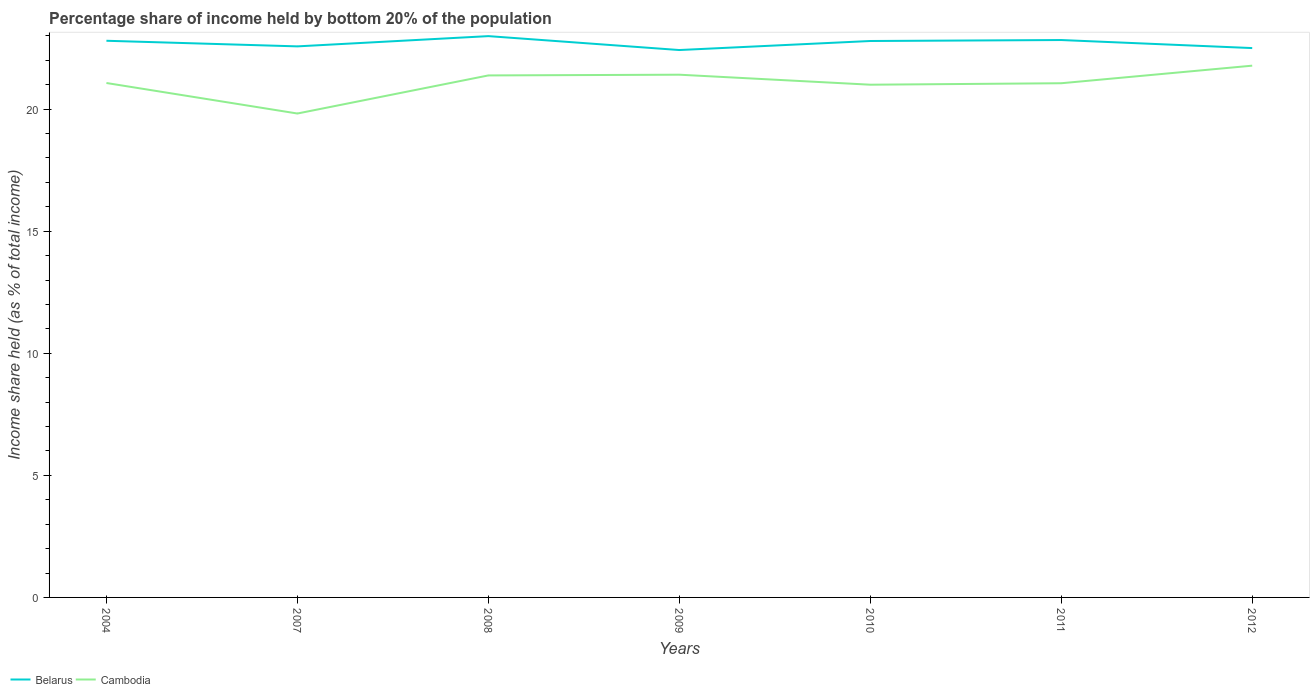How many different coloured lines are there?
Provide a succinct answer. 2. Is the number of lines equal to the number of legend labels?
Ensure brevity in your answer.  Yes. Across all years, what is the maximum share of income held by bottom 20% of the population in Cambodia?
Provide a succinct answer. 19.82. What is the total share of income held by bottom 20% of the population in Belarus in the graph?
Provide a short and direct response. -0.04. What is the difference between the highest and the second highest share of income held by bottom 20% of the population in Cambodia?
Ensure brevity in your answer.  1.96. What is the difference between the highest and the lowest share of income held by bottom 20% of the population in Cambodia?
Your response must be concise. 3. How many years are there in the graph?
Give a very brief answer. 7. What is the difference between two consecutive major ticks on the Y-axis?
Provide a succinct answer. 5. Does the graph contain grids?
Provide a succinct answer. No. Where does the legend appear in the graph?
Your response must be concise. Bottom left. What is the title of the graph?
Keep it short and to the point. Percentage share of income held by bottom 20% of the population. Does "St. Vincent and the Grenadines" appear as one of the legend labels in the graph?
Ensure brevity in your answer.  No. What is the label or title of the Y-axis?
Offer a very short reply. Income share held (as % of total income). What is the Income share held (as % of total income) of Belarus in 2004?
Offer a very short reply. 22.8. What is the Income share held (as % of total income) in Cambodia in 2004?
Your answer should be compact. 21.07. What is the Income share held (as % of total income) in Belarus in 2007?
Keep it short and to the point. 22.57. What is the Income share held (as % of total income) in Cambodia in 2007?
Your response must be concise. 19.82. What is the Income share held (as % of total income) in Belarus in 2008?
Provide a succinct answer. 22.99. What is the Income share held (as % of total income) of Cambodia in 2008?
Offer a very short reply. 21.38. What is the Income share held (as % of total income) of Belarus in 2009?
Keep it short and to the point. 22.42. What is the Income share held (as % of total income) in Cambodia in 2009?
Your response must be concise. 21.41. What is the Income share held (as % of total income) of Belarus in 2010?
Offer a very short reply. 22.79. What is the Income share held (as % of total income) of Belarus in 2011?
Your answer should be compact. 22.83. What is the Income share held (as % of total income) in Cambodia in 2011?
Provide a short and direct response. 21.06. What is the Income share held (as % of total income) of Cambodia in 2012?
Your answer should be compact. 21.78. Across all years, what is the maximum Income share held (as % of total income) in Belarus?
Your response must be concise. 22.99. Across all years, what is the maximum Income share held (as % of total income) of Cambodia?
Give a very brief answer. 21.78. Across all years, what is the minimum Income share held (as % of total income) of Belarus?
Keep it short and to the point. 22.42. Across all years, what is the minimum Income share held (as % of total income) of Cambodia?
Your response must be concise. 19.82. What is the total Income share held (as % of total income) of Belarus in the graph?
Make the answer very short. 158.9. What is the total Income share held (as % of total income) in Cambodia in the graph?
Your response must be concise. 147.52. What is the difference between the Income share held (as % of total income) of Belarus in 2004 and that in 2007?
Your response must be concise. 0.23. What is the difference between the Income share held (as % of total income) of Belarus in 2004 and that in 2008?
Your response must be concise. -0.19. What is the difference between the Income share held (as % of total income) in Cambodia in 2004 and that in 2008?
Offer a very short reply. -0.31. What is the difference between the Income share held (as % of total income) in Belarus in 2004 and that in 2009?
Make the answer very short. 0.38. What is the difference between the Income share held (as % of total income) of Cambodia in 2004 and that in 2009?
Your answer should be compact. -0.34. What is the difference between the Income share held (as % of total income) in Belarus in 2004 and that in 2010?
Your answer should be very brief. 0.01. What is the difference between the Income share held (as % of total income) in Cambodia in 2004 and that in 2010?
Offer a terse response. 0.07. What is the difference between the Income share held (as % of total income) of Belarus in 2004 and that in 2011?
Keep it short and to the point. -0.03. What is the difference between the Income share held (as % of total income) of Cambodia in 2004 and that in 2011?
Your response must be concise. 0.01. What is the difference between the Income share held (as % of total income) of Belarus in 2004 and that in 2012?
Offer a very short reply. 0.3. What is the difference between the Income share held (as % of total income) of Cambodia in 2004 and that in 2012?
Make the answer very short. -0.71. What is the difference between the Income share held (as % of total income) of Belarus in 2007 and that in 2008?
Offer a terse response. -0.42. What is the difference between the Income share held (as % of total income) in Cambodia in 2007 and that in 2008?
Provide a succinct answer. -1.56. What is the difference between the Income share held (as % of total income) in Belarus in 2007 and that in 2009?
Make the answer very short. 0.15. What is the difference between the Income share held (as % of total income) of Cambodia in 2007 and that in 2009?
Ensure brevity in your answer.  -1.59. What is the difference between the Income share held (as % of total income) of Belarus in 2007 and that in 2010?
Offer a terse response. -0.22. What is the difference between the Income share held (as % of total income) of Cambodia in 2007 and that in 2010?
Your answer should be compact. -1.18. What is the difference between the Income share held (as % of total income) of Belarus in 2007 and that in 2011?
Offer a very short reply. -0.26. What is the difference between the Income share held (as % of total income) in Cambodia in 2007 and that in 2011?
Offer a terse response. -1.24. What is the difference between the Income share held (as % of total income) of Belarus in 2007 and that in 2012?
Your response must be concise. 0.07. What is the difference between the Income share held (as % of total income) in Cambodia in 2007 and that in 2012?
Your answer should be very brief. -1.96. What is the difference between the Income share held (as % of total income) in Belarus in 2008 and that in 2009?
Make the answer very short. 0.57. What is the difference between the Income share held (as % of total income) in Cambodia in 2008 and that in 2009?
Your answer should be very brief. -0.03. What is the difference between the Income share held (as % of total income) of Cambodia in 2008 and that in 2010?
Keep it short and to the point. 0.38. What is the difference between the Income share held (as % of total income) in Belarus in 2008 and that in 2011?
Your response must be concise. 0.16. What is the difference between the Income share held (as % of total income) in Cambodia in 2008 and that in 2011?
Make the answer very short. 0.32. What is the difference between the Income share held (as % of total income) of Belarus in 2008 and that in 2012?
Your answer should be very brief. 0.49. What is the difference between the Income share held (as % of total income) in Cambodia in 2008 and that in 2012?
Your response must be concise. -0.4. What is the difference between the Income share held (as % of total income) in Belarus in 2009 and that in 2010?
Give a very brief answer. -0.37. What is the difference between the Income share held (as % of total income) of Cambodia in 2009 and that in 2010?
Provide a short and direct response. 0.41. What is the difference between the Income share held (as % of total income) in Belarus in 2009 and that in 2011?
Provide a succinct answer. -0.41. What is the difference between the Income share held (as % of total income) in Cambodia in 2009 and that in 2011?
Provide a succinct answer. 0.35. What is the difference between the Income share held (as % of total income) of Belarus in 2009 and that in 2012?
Keep it short and to the point. -0.08. What is the difference between the Income share held (as % of total income) of Cambodia in 2009 and that in 2012?
Your answer should be compact. -0.37. What is the difference between the Income share held (as % of total income) of Belarus in 2010 and that in 2011?
Offer a terse response. -0.04. What is the difference between the Income share held (as % of total income) in Cambodia in 2010 and that in 2011?
Your answer should be very brief. -0.06. What is the difference between the Income share held (as % of total income) of Belarus in 2010 and that in 2012?
Your answer should be very brief. 0.29. What is the difference between the Income share held (as % of total income) of Cambodia in 2010 and that in 2012?
Make the answer very short. -0.78. What is the difference between the Income share held (as % of total income) in Belarus in 2011 and that in 2012?
Your response must be concise. 0.33. What is the difference between the Income share held (as % of total income) of Cambodia in 2011 and that in 2012?
Your answer should be very brief. -0.72. What is the difference between the Income share held (as % of total income) in Belarus in 2004 and the Income share held (as % of total income) in Cambodia in 2007?
Provide a short and direct response. 2.98. What is the difference between the Income share held (as % of total income) of Belarus in 2004 and the Income share held (as % of total income) of Cambodia in 2008?
Your answer should be very brief. 1.42. What is the difference between the Income share held (as % of total income) of Belarus in 2004 and the Income share held (as % of total income) of Cambodia in 2009?
Offer a very short reply. 1.39. What is the difference between the Income share held (as % of total income) in Belarus in 2004 and the Income share held (as % of total income) in Cambodia in 2010?
Keep it short and to the point. 1.8. What is the difference between the Income share held (as % of total income) of Belarus in 2004 and the Income share held (as % of total income) of Cambodia in 2011?
Give a very brief answer. 1.74. What is the difference between the Income share held (as % of total income) of Belarus in 2004 and the Income share held (as % of total income) of Cambodia in 2012?
Your answer should be compact. 1.02. What is the difference between the Income share held (as % of total income) in Belarus in 2007 and the Income share held (as % of total income) in Cambodia in 2008?
Offer a terse response. 1.19. What is the difference between the Income share held (as % of total income) of Belarus in 2007 and the Income share held (as % of total income) of Cambodia in 2009?
Offer a very short reply. 1.16. What is the difference between the Income share held (as % of total income) of Belarus in 2007 and the Income share held (as % of total income) of Cambodia in 2010?
Your answer should be compact. 1.57. What is the difference between the Income share held (as % of total income) of Belarus in 2007 and the Income share held (as % of total income) of Cambodia in 2011?
Your answer should be very brief. 1.51. What is the difference between the Income share held (as % of total income) of Belarus in 2007 and the Income share held (as % of total income) of Cambodia in 2012?
Your answer should be compact. 0.79. What is the difference between the Income share held (as % of total income) in Belarus in 2008 and the Income share held (as % of total income) in Cambodia in 2009?
Your answer should be compact. 1.58. What is the difference between the Income share held (as % of total income) of Belarus in 2008 and the Income share held (as % of total income) of Cambodia in 2010?
Your response must be concise. 1.99. What is the difference between the Income share held (as % of total income) of Belarus in 2008 and the Income share held (as % of total income) of Cambodia in 2011?
Provide a succinct answer. 1.93. What is the difference between the Income share held (as % of total income) in Belarus in 2008 and the Income share held (as % of total income) in Cambodia in 2012?
Make the answer very short. 1.21. What is the difference between the Income share held (as % of total income) in Belarus in 2009 and the Income share held (as % of total income) in Cambodia in 2010?
Provide a short and direct response. 1.42. What is the difference between the Income share held (as % of total income) in Belarus in 2009 and the Income share held (as % of total income) in Cambodia in 2011?
Your answer should be compact. 1.36. What is the difference between the Income share held (as % of total income) in Belarus in 2009 and the Income share held (as % of total income) in Cambodia in 2012?
Give a very brief answer. 0.64. What is the difference between the Income share held (as % of total income) of Belarus in 2010 and the Income share held (as % of total income) of Cambodia in 2011?
Offer a very short reply. 1.73. What is the average Income share held (as % of total income) in Belarus per year?
Offer a very short reply. 22.7. What is the average Income share held (as % of total income) of Cambodia per year?
Your answer should be compact. 21.07. In the year 2004, what is the difference between the Income share held (as % of total income) of Belarus and Income share held (as % of total income) of Cambodia?
Your answer should be compact. 1.73. In the year 2007, what is the difference between the Income share held (as % of total income) of Belarus and Income share held (as % of total income) of Cambodia?
Your answer should be very brief. 2.75. In the year 2008, what is the difference between the Income share held (as % of total income) in Belarus and Income share held (as % of total income) in Cambodia?
Offer a very short reply. 1.61. In the year 2010, what is the difference between the Income share held (as % of total income) of Belarus and Income share held (as % of total income) of Cambodia?
Your answer should be very brief. 1.79. In the year 2011, what is the difference between the Income share held (as % of total income) in Belarus and Income share held (as % of total income) in Cambodia?
Make the answer very short. 1.77. In the year 2012, what is the difference between the Income share held (as % of total income) in Belarus and Income share held (as % of total income) in Cambodia?
Provide a short and direct response. 0.72. What is the ratio of the Income share held (as % of total income) of Belarus in 2004 to that in 2007?
Your answer should be very brief. 1.01. What is the ratio of the Income share held (as % of total income) of Cambodia in 2004 to that in 2007?
Ensure brevity in your answer.  1.06. What is the ratio of the Income share held (as % of total income) of Cambodia in 2004 to that in 2008?
Provide a short and direct response. 0.99. What is the ratio of the Income share held (as % of total income) in Belarus in 2004 to that in 2009?
Provide a succinct answer. 1.02. What is the ratio of the Income share held (as % of total income) of Cambodia in 2004 to that in 2009?
Provide a short and direct response. 0.98. What is the ratio of the Income share held (as % of total income) in Belarus in 2004 to that in 2010?
Keep it short and to the point. 1. What is the ratio of the Income share held (as % of total income) of Cambodia in 2004 to that in 2010?
Provide a succinct answer. 1. What is the ratio of the Income share held (as % of total income) of Belarus in 2004 to that in 2012?
Keep it short and to the point. 1.01. What is the ratio of the Income share held (as % of total income) in Cambodia in 2004 to that in 2012?
Keep it short and to the point. 0.97. What is the ratio of the Income share held (as % of total income) of Belarus in 2007 to that in 2008?
Offer a very short reply. 0.98. What is the ratio of the Income share held (as % of total income) of Cambodia in 2007 to that in 2008?
Ensure brevity in your answer.  0.93. What is the ratio of the Income share held (as % of total income) of Belarus in 2007 to that in 2009?
Offer a very short reply. 1.01. What is the ratio of the Income share held (as % of total income) of Cambodia in 2007 to that in 2009?
Offer a very short reply. 0.93. What is the ratio of the Income share held (as % of total income) of Belarus in 2007 to that in 2010?
Give a very brief answer. 0.99. What is the ratio of the Income share held (as % of total income) in Cambodia in 2007 to that in 2010?
Your response must be concise. 0.94. What is the ratio of the Income share held (as % of total income) of Cambodia in 2007 to that in 2011?
Your answer should be very brief. 0.94. What is the ratio of the Income share held (as % of total income) in Belarus in 2007 to that in 2012?
Your answer should be very brief. 1. What is the ratio of the Income share held (as % of total income) of Cambodia in 2007 to that in 2012?
Offer a very short reply. 0.91. What is the ratio of the Income share held (as % of total income) of Belarus in 2008 to that in 2009?
Provide a succinct answer. 1.03. What is the ratio of the Income share held (as % of total income) in Belarus in 2008 to that in 2010?
Provide a succinct answer. 1.01. What is the ratio of the Income share held (as % of total income) of Cambodia in 2008 to that in 2010?
Your response must be concise. 1.02. What is the ratio of the Income share held (as % of total income) of Belarus in 2008 to that in 2011?
Provide a short and direct response. 1.01. What is the ratio of the Income share held (as % of total income) in Cambodia in 2008 to that in 2011?
Your answer should be very brief. 1.02. What is the ratio of the Income share held (as % of total income) of Belarus in 2008 to that in 2012?
Offer a terse response. 1.02. What is the ratio of the Income share held (as % of total income) in Cambodia in 2008 to that in 2012?
Keep it short and to the point. 0.98. What is the ratio of the Income share held (as % of total income) of Belarus in 2009 to that in 2010?
Provide a succinct answer. 0.98. What is the ratio of the Income share held (as % of total income) of Cambodia in 2009 to that in 2010?
Offer a terse response. 1.02. What is the ratio of the Income share held (as % of total income) of Belarus in 2009 to that in 2011?
Offer a very short reply. 0.98. What is the ratio of the Income share held (as % of total income) in Cambodia in 2009 to that in 2011?
Keep it short and to the point. 1.02. What is the ratio of the Income share held (as % of total income) in Belarus in 2009 to that in 2012?
Your answer should be very brief. 1. What is the ratio of the Income share held (as % of total income) of Cambodia in 2009 to that in 2012?
Your answer should be compact. 0.98. What is the ratio of the Income share held (as % of total income) in Belarus in 2010 to that in 2011?
Ensure brevity in your answer.  1. What is the ratio of the Income share held (as % of total income) in Belarus in 2010 to that in 2012?
Your response must be concise. 1.01. What is the ratio of the Income share held (as % of total income) in Cambodia in 2010 to that in 2012?
Provide a short and direct response. 0.96. What is the ratio of the Income share held (as % of total income) in Belarus in 2011 to that in 2012?
Your response must be concise. 1.01. What is the ratio of the Income share held (as % of total income) of Cambodia in 2011 to that in 2012?
Give a very brief answer. 0.97. What is the difference between the highest and the second highest Income share held (as % of total income) of Belarus?
Your response must be concise. 0.16. What is the difference between the highest and the second highest Income share held (as % of total income) in Cambodia?
Make the answer very short. 0.37. What is the difference between the highest and the lowest Income share held (as % of total income) of Belarus?
Provide a short and direct response. 0.57. What is the difference between the highest and the lowest Income share held (as % of total income) of Cambodia?
Your answer should be very brief. 1.96. 